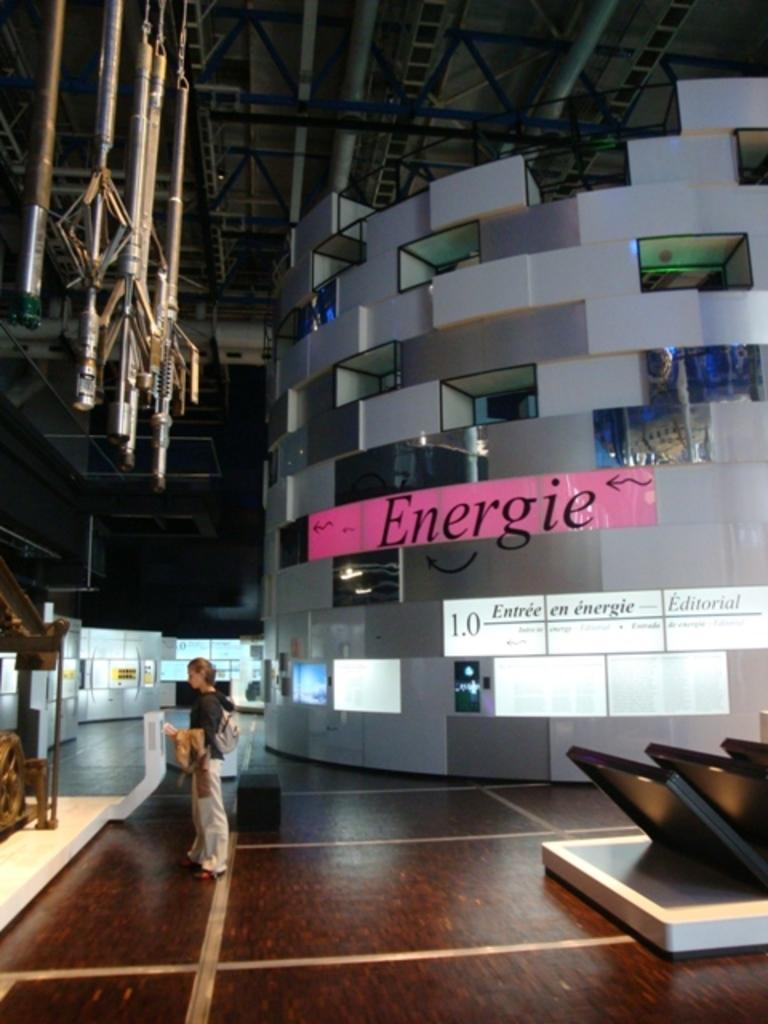<image>
Present a compact description of the photo's key features. a place where a man stands and it says Energie in the background. 